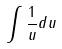Convert formula to latex. <formula><loc_0><loc_0><loc_500><loc_500>\int \frac { 1 } { u } d u</formula> 